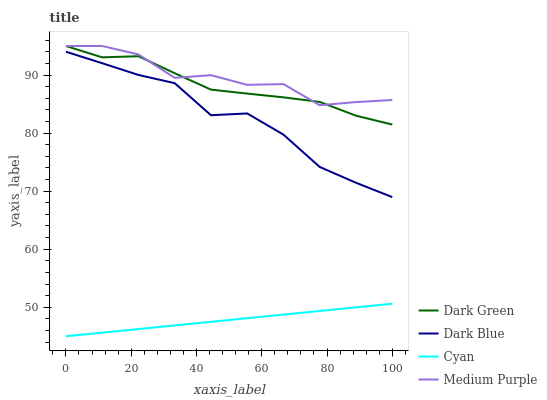Does Dark Blue have the minimum area under the curve?
Answer yes or no. No. Does Dark Blue have the maximum area under the curve?
Answer yes or no. No. Is Dark Blue the smoothest?
Answer yes or no. No. Is Dark Blue the roughest?
Answer yes or no. No. Does Dark Blue have the lowest value?
Answer yes or no. No. Does Dark Blue have the highest value?
Answer yes or no. No. Is Dark Blue less than Medium Purple?
Answer yes or no. Yes. Is Medium Purple greater than Dark Blue?
Answer yes or no. Yes. Does Dark Blue intersect Medium Purple?
Answer yes or no. No. 